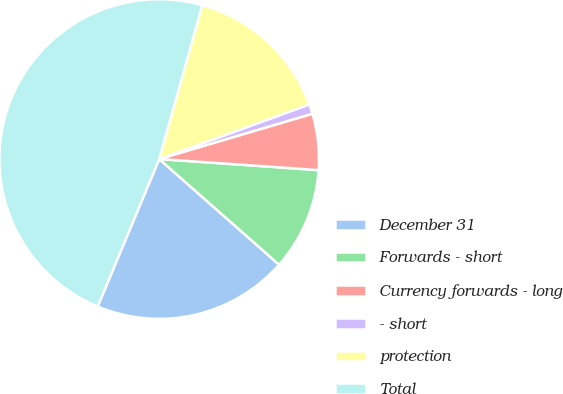<chart> <loc_0><loc_0><loc_500><loc_500><pie_chart><fcel>December 31<fcel>Forwards - short<fcel>Currency forwards - long<fcel>- short<fcel>protection<fcel>Total<nl><fcel>19.8%<fcel>10.39%<fcel>5.68%<fcel>0.98%<fcel>15.1%<fcel>48.05%<nl></chart> 